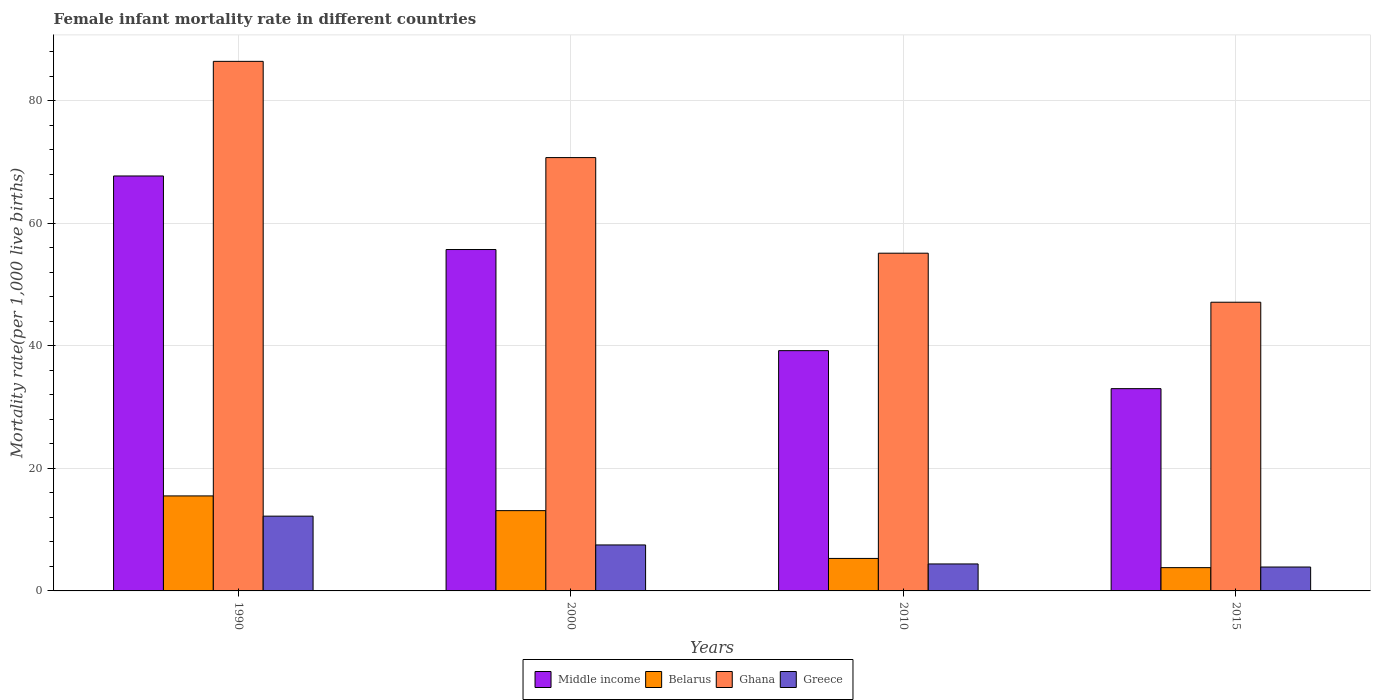How many different coloured bars are there?
Offer a very short reply. 4. Are the number of bars on each tick of the X-axis equal?
Provide a short and direct response. Yes. How many bars are there on the 1st tick from the left?
Give a very brief answer. 4. In how many cases, is the number of bars for a given year not equal to the number of legend labels?
Ensure brevity in your answer.  0. What is the female infant mortality rate in Greece in 2010?
Keep it short and to the point. 4.4. Across all years, what is the maximum female infant mortality rate in Ghana?
Give a very brief answer. 86.4. In which year was the female infant mortality rate in Greece minimum?
Make the answer very short. 2015. What is the total female infant mortality rate in Ghana in the graph?
Keep it short and to the point. 259.3. What is the difference between the female infant mortality rate in Greece in 2000 and that in 2015?
Ensure brevity in your answer.  3.6. What is the average female infant mortality rate in Middle income per year?
Give a very brief answer. 48.9. In the year 1990, what is the difference between the female infant mortality rate in Belarus and female infant mortality rate in Ghana?
Make the answer very short. -70.9. What is the ratio of the female infant mortality rate in Greece in 2000 to that in 2015?
Provide a succinct answer. 1.92. Is the difference between the female infant mortality rate in Belarus in 1990 and 2015 greater than the difference between the female infant mortality rate in Ghana in 1990 and 2015?
Keep it short and to the point. No. What is the difference between the highest and the second highest female infant mortality rate in Greece?
Ensure brevity in your answer.  4.7. What is the difference between the highest and the lowest female infant mortality rate in Middle income?
Keep it short and to the point. 34.7. Is it the case that in every year, the sum of the female infant mortality rate in Greece and female infant mortality rate in Ghana is greater than the sum of female infant mortality rate in Middle income and female infant mortality rate in Belarus?
Provide a succinct answer. No. How many bars are there?
Keep it short and to the point. 16. What is the difference between two consecutive major ticks on the Y-axis?
Ensure brevity in your answer.  20. Does the graph contain any zero values?
Offer a very short reply. No. How many legend labels are there?
Provide a succinct answer. 4. What is the title of the graph?
Keep it short and to the point. Female infant mortality rate in different countries. What is the label or title of the Y-axis?
Offer a very short reply. Mortality rate(per 1,0 live births). What is the Mortality rate(per 1,000 live births) of Middle income in 1990?
Offer a terse response. 67.7. What is the Mortality rate(per 1,000 live births) of Ghana in 1990?
Keep it short and to the point. 86.4. What is the Mortality rate(per 1,000 live births) of Middle income in 2000?
Provide a short and direct response. 55.7. What is the Mortality rate(per 1,000 live births) in Ghana in 2000?
Offer a very short reply. 70.7. What is the Mortality rate(per 1,000 live births) of Middle income in 2010?
Provide a short and direct response. 39.2. What is the Mortality rate(per 1,000 live births) in Belarus in 2010?
Offer a terse response. 5.3. What is the Mortality rate(per 1,000 live births) of Ghana in 2010?
Make the answer very short. 55.1. What is the Mortality rate(per 1,000 live births) of Ghana in 2015?
Provide a short and direct response. 47.1. Across all years, what is the maximum Mortality rate(per 1,000 live births) in Middle income?
Ensure brevity in your answer.  67.7. Across all years, what is the maximum Mortality rate(per 1,000 live births) in Ghana?
Provide a succinct answer. 86.4. Across all years, what is the maximum Mortality rate(per 1,000 live births) of Greece?
Make the answer very short. 12.2. Across all years, what is the minimum Mortality rate(per 1,000 live births) in Middle income?
Your answer should be compact. 33. Across all years, what is the minimum Mortality rate(per 1,000 live births) of Belarus?
Ensure brevity in your answer.  3.8. Across all years, what is the minimum Mortality rate(per 1,000 live births) in Ghana?
Provide a succinct answer. 47.1. What is the total Mortality rate(per 1,000 live births) in Middle income in the graph?
Your response must be concise. 195.6. What is the total Mortality rate(per 1,000 live births) of Belarus in the graph?
Your answer should be very brief. 37.7. What is the total Mortality rate(per 1,000 live births) of Ghana in the graph?
Keep it short and to the point. 259.3. What is the difference between the Mortality rate(per 1,000 live births) in Middle income in 1990 and that in 2000?
Keep it short and to the point. 12. What is the difference between the Mortality rate(per 1,000 live births) in Belarus in 1990 and that in 2000?
Offer a very short reply. 2.4. What is the difference between the Mortality rate(per 1,000 live births) in Middle income in 1990 and that in 2010?
Your answer should be compact. 28.5. What is the difference between the Mortality rate(per 1,000 live births) of Ghana in 1990 and that in 2010?
Ensure brevity in your answer.  31.3. What is the difference between the Mortality rate(per 1,000 live births) of Greece in 1990 and that in 2010?
Your answer should be compact. 7.8. What is the difference between the Mortality rate(per 1,000 live births) of Middle income in 1990 and that in 2015?
Offer a very short reply. 34.7. What is the difference between the Mortality rate(per 1,000 live births) in Belarus in 1990 and that in 2015?
Offer a terse response. 11.7. What is the difference between the Mortality rate(per 1,000 live births) in Ghana in 1990 and that in 2015?
Your response must be concise. 39.3. What is the difference between the Mortality rate(per 1,000 live births) of Greece in 2000 and that in 2010?
Provide a succinct answer. 3.1. What is the difference between the Mortality rate(per 1,000 live births) of Middle income in 2000 and that in 2015?
Ensure brevity in your answer.  22.7. What is the difference between the Mortality rate(per 1,000 live births) of Ghana in 2000 and that in 2015?
Provide a succinct answer. 23.6. What is the difference between the Mortality rate(per 1,000 live births) in Greece in 2000 and that in 2015?
Ensure brevity in your answer.  3.6. What is the difference between the Mortality rate(per 1,000 live births) in Middle income in 1990 and the Mortality rate(per 1,000 live births) in Belarus in 2000?
Offer a very short reply. 54.6. What is the difference between the Mortality rate(per 1,000 live births) in Middle income in 1990 and the Mortality rate(per 1,000 live births) in Ghana in 2000?
Your answer should be very brief. -3. What is the difference between the Mortality rate(per 1,000 live births) of Middle income in 1990 and the Mortality rate(per 1,000 live births) of Greece in 2000?
Provide a succinct answer. 60.2. What is the difference between the Mortality rate(per 1,000 live births) of Belarus in 1990 and the Mortality rate(per 1,000 live births) of Ghana in 2000?
Offer a terse response. -55.2. What is the difference between the Mortality rate(per 1,000 live births) of Belarus in 1990 and the Mortality rate(per 1,000 live births) of Greece in 2000?
Make the answer very short. 8. What is the difference between the Mortality rate(per 1,000 live births) in Ghana in 1990 and the Mortality rate(per 1,000 live births) in Greece in 2000?
Provide a succinct answer. 78.9. What is the difference between the Mortality rate(per 1,000 live births) in Middle income in 1990 and the Mortality rate(per 1,000 live births) in Belarus in 2010?
Offer a terse response. 62.4. What is the difference between the Mortality rate(per 1,000 live births) of Middle income in 1990 and the Mortality rate(per 1,000 live births) of Greece in 2010?
Keep it short and to the point. 63.3. What is the difference between the Mortality rate(per 1,000 live births) in Belarus in 1990 and the Mortality rate(per 1,000 live births) in Ghana in 2010?
Give a very brief answer. -39.6. What is the difference between the Mortality rate(per 1,000 live births) of Belarus in 1990 and the Mortality rate(per 1,000 live births) of Greece in 2010?
Ensure brevity in your answer.  11.1. What is the difference between the Mortality rate(per 1,000 live births) in Ghana in 1990 and the Mortality rate(per 1,000 live births) in Greece in 2010?
Make the answer very short. 82. What is the difference between the Mortality rate(per 1,000 live births) in Middle income in 1990 and the Mortality rate(per 1,000 live births) in Belarus in 2015?
Offer a terse response. 63.9. What is the difference between the Mortality rate(per 1,000 live births) in Middle income in 1990 and the Mortality rate(per 1,000 live births) in Ghana in 2015?
Your answer should be compact. 20.6. What is the difference between the Mortality rate(per 1,000 live births) in Middle income in 1990 and the Mortality rate(per 1,000 live births) in Greece in 2015?
Offer a very short reply. 63.8. What is the difference between the Mortality rate(per 1,000 live births) of Belarus in 1990 and the Mortality rate(per 1,000 live births) of Ghana in 2015?
Your answer should be compact. -31.6. What is the difference between the Mortality rate(per 1,000 live births) of Belarus in 1990 and the Mortality rate(per 1,000 live births) of Greece in 2015?
Your response must be concise. 11.6. What is the difference between the Mortality rate(per 1,000 live births) in Ghana in 1990 and the Mortality rate(per 1,000 live births) in Greece in 2015?
Make the answer very short. 82.5. What is the difference between the Mortality rate(per 1,000 live births) in Middle income in 2000 and the Mortality rate(per 1,000 live births) in Belarus in 2010?
Your response must be concise. 50.4. What is the difference between the Mortality rate(per 1,000 live births) of Middle income in 2000 and the Mortality rate(per 1,000 live births) of Ghana in 2010?
Ensure brevity in your answer.  0.6. What is the difference between the Mortality rate(per 1,000 live births) of Middle income in 2000 and the Mortality rate(per 1,000 live births) of Greece in 2010?
Offer a terse response. 51.3. What is the difference between the Mortality rate(per 1,000 live births) in Belarus in 2000 and the Mortality rate(per 1,000 live births) in Ghana in 2010?
Your answer should be very brief. -42. What is the difference between the Mortality rate(per 1,000 live births) of Ghana in 2000 and the Mortality rate(per 1,000 live births) of Greece in 2010?
Your answer should be very brief. 66.3. What is the difference between the Mortality rate(per 1,000 live births) of Middle income in 2000 and the Mortality rate(per 1,000 live births) of Belarus in 2015?
Ensure brevity in your answer.  51.9. What is the difference between the Mortality rate(per 1,000 live births) in Middle income in 2000 and the Mortality rate(per 1,000 live births) in Greece in 2015?
Keep it short and to the point. 51.8. What is the difference between the Mortality rate(per 1,000 live births) in Belarus in 2000 and the Mortality rate(per 1,000 live births) in Ghana in 2015?
Ensure brevity in your answer.  -34. What is the difference between the Mortality rate(per 1,000 live births) of Belarus in 2000 and the Mortality rate(per 1,000 live births) of Greece in 2015?
Provide a short and direct response. 9.2. What is the difference between the Mortality rate(per 1,000 live births) in Ghana in 2000 and the Mortality rate(per 1,000 live births) in Greece in 2015?
Provide a short and direct response. 66.8. What is the difference between the Mortality rate(per 1,000 live births) in Middle income in 2010 and the Mortality rate(per 1,000 live births) in Belarus in 2015?
Make the answer very short. 35.4. What is the difference between the Mortality rate(per 1,000 live births) of Middle income in 2010 and the Mortality rate(per 1,000 live births) of Ghana in 2015?
Your answer should be compact. -7.9. What is the difference between the Mortality rate(per 1,000 live births) of Middle income in 2010 and the Mortality rate(per 1,000 live births) of Greece in 2015?
Keep it short and to the point. 35.3. What is the difference between the Mortality rate(per 1,000 live births) of Belarus in 2010 and the Mortality rate(per 1,000 live births) of Ghana in 2015?
Offer a terse response. -41.8. What is the difference between the Mortality rate(per 1,000 live births) of Belarus in 2010 and the Mortality rate(per 1,000 live births) of Greece in 2015?
Offer a very short reply. 1.4. What is the difference between the Mortality rate(per 1,000 live births) in Ghana in 2010 and the Mortality rate(per 1,000 live births) in Greece in 2015?
Ensure brevity in your answer.  51.2. What is the average Mortality rate(per 1,000 live births) in Middle income per year?
Offer a terse response. 48.9. What is the average Mortality rate(per 1,000 live births) of Belarus per year?
Ensure brevity in your answer.  9.43. What is the average Mortality rate(per 1,000 live births) of Ghana per year?
Your response must be concise. 64.83. What is the average Mortality rate(per 1,000 live births) in Greece per year?
Ensure brevity in your answer.  7. In the year 1990, what is the difference between the Mortality rate(per 1,000 live births) in Middle income and Mortality rate(per 1,000 live births) in Belarus?
Your response must be concise. 52.2. In the year 1990, what is the difference between the Mortality rate(per 1,000 live births) of Middle income and Mortality rate(per 1,000 live births) of Ghana?
Keep it short and to the point. -18.7. In the year 1990, what is the difference between the Mortality rate(per 1,000 live births) in Middle income and Mortality rate(per 1,000 live births) in Greece?
Give a very brief answer. 55.5. In the year 1990, what is the difference between the Mortality rate(per 1,000 live births) of Belarus and Mortality rate(per 1,000 live births) of Ghana?
Offer a very short reply. -70.9. In the year 1990, what is the difference between the Mortality rate(per 1,000 live births) in Ghana and Mortality rate(per 1,000 live births) in Greece?
Give a very brief answer. 74.2. In the year 2000, what is the difference between the Mortality rate(per 1,000 live births) of Middle income and Mortality rate(per 1,000 live births) of Belarus?
Provide a short and direct response. 42.6. In the year 2000, what is the difference between the Mortality rate(per 1,000 live births) of Middle income and Mortality rate(per 1,000 live births) of Greece?
Your response must be concise. 48.2. In the year 2000, what is the difference between the Mortality rate(per 1,000 live births) of Belarus and Mortality rate(per 1,000 live births) of Ghana?
Your answer should be compact. -57.6. In the year 2000, what is the difference between the Mortality rate(per 1,000 live births) in Ghana and Mortality rate(per 1,000 live births) in Greece?
Your answer should be compact. 63.2. In the year 2010, what is the difference between the Mortality rate(per 1,000 live births) of Middle income and Mortality rate(per 1,000 live births) of Belarus?
Ensure brevity in your answer.  33.9. In the year 2010, what is the difference between the Mortality rate(per 1,000 live births) of Middle income and Mortality rate(per 1,000 live births) of Ghana?
Provide a succinct answer. -15.9. In the year 2010, what is the difference between the Mortality rate(per 1,000 live births) in Middle income and Mortality rate(per 1,000 live births) in Greece?
Your answer should be compact. 34.8. In the year 2010, what is the difference between the Mortality rate(per 1,000 live births) in Belarus and Mortality rate(per 1,000 live births) in Ghana?
Provide a succinct answer. -49.8. In the year 2010, what is the difference between the Mortality rate(per 1,000 live births) in Ghana and Mortality rate(per 1,000 live births) in Greece?
Keep it short and to the point. 50.7. In the year 2015, what is the difference between the Mortality rate(per 1,000 live births) in Middle income and Mortality rate(per 1,000 live births) in Belarus?
Ensure brevity in your answer.  29.2. In the year 2015, what is the difference between the Mortality rate(per 1,000 live births) in Middle income and Mortality rate(per 1,000 live births) in Ghana?
Make the answer very short. -14.1. In the year 2015, what is the difference between the Mortality rate(per 1,000 live births) in Middle income and Mortality rate(per 1,000 live births) in Greece?
Offer a terse response. 29.1. In the year 2015, what is the difference between the Mortality rate(per 1,000 live births) in Belarus and Mortality rate(per 1,000 live births) in Ghana?
Ensure brevity in your answer.  -43.3. In the year 2015, what is the difference between the Mortality rate(per 1,000 live births) of Belarus and Mortality rate(per 1,000 live births) of Greece?
Give a very brief answer. -0.1. In the year 2015, what is the difference between the Mortality rate(per 1,000 live births) in Ghana and Mortality rate(per 1,000 live births) in Greece?
Offer a very short reply. 43.2. What is the ratio of the Mortality rate(per 1,000 live births) of Middle income in 1990 to that in 2000?
Ensure brevity in your answer.  1.22. What is the ratio of the Mortality rate(per 1,000 live births) in Belarus in 1990 to that in 2000?
Your answer should be compact. 1.18. What is the ratio of the Mortality rate(per 1,000 live births) of Ghana in 1990 to that in 2000?
Give a very brief answer. 1.22. What is the ratio of the Mortality rate(per 1,000 live births) of Greece in 1990 to that in 2000?
Your answer should be compact. 1.63. What is the ratio of the Mortality rate(per 1,000 live births) of Middle income in 1990 to that in 2010?
Offer a terse response. 1.73. What is the ratio of the Mortality rate(per 1,000 live births) in Belarus in 1990 to that in 2010?
Provide a succinct answer. 2.92. What is the ratio of the Mortality rate(per 1,000 live births) in Ghana in 1990 to that in 2010?
Provide a succinct answer. 1.57. What is the ratio of the Mortality rate(per 1,000 live births) of Greece in 1990 to that in 2010?
Make the answer very short. 2.77. What is the ratio of the Mortality rate(per 1,000 live births) in Middle income in 1990 to that in 2015?
Keep it short and to the point. 2.05. What is the ratio of the Mortality rate(per 1,000 live births) in Belarus in 1990 to that in 2015?
Make the answer very short. 4.08. What is the ratio of the Mortality rate(per 1,000 live births) in Ghana in 1990 to that in 2015?
Your answer should be compact. 1.83. What is the ratio of the Mortality rate(per 1,000 live births) of Greece in 1990 to that in 2015?
Keep it short and to the point. 3.13. What is the ratio of the Mortality rate(per 1,000 live births) in Middle income in 2000 to that in 2010?
Your answer should be compact. 1.42. What is the ratio of the Mortality rate(per 1,000 live births) of Belarus in 2000 to that in 2010?
Provide a succinct answer. 2.47. What is the ratio of the Mortality rate(per 1,000 live births) of Ghana in 2000 to that in 2010?
Offer a very short reply. 1.28. What is the ratio of the Mortality rate(per 1,000 live births) in Greece in 2000 to that in 2010?
Keep it short and to the point. 1.7. What is the ratio of the Mortality rate(per 1,000 live births) in Middle income in 2000 to that in 2015?
Offer a very short reply. 1.69. What is the ratio of the Mortality rate(per 1,000 live births) in Belarus in 2000 to that in 2015?
Give a very brief answer. 3.45. What is the ratio of the Mortality rate(per 1,000 live births) of Ghana in 2000 to that in 2015?
Your answer should be compact. 1.5. What is the ratio of the Mortality rate(per 1,000 live births) of Greece in 2000 to that in 2015?
Offer a very short reply. 1.92. What is the ratio of the Mortality rate(per 1,000 live births) of Middle income in 2010 to that in 2015?
Your answer should be very brief. 1.19. What is the ratio of the Mortality rate(per 1,000 live births) of Belarus in 2010 to that in 2015?
Offer a very short reply. 1.39. What is the ratio of the Mortality rate(per 1,000 live births) in Ghana in 2010 to that in 2015?
Give a very brief answer. 1.17. What is the ratio of the Mortality rate(per 1,000 live births) in Greece in 2010 to that in 2015?
Offer a terse response. 1.13. What is the difference between the highest and the second highest Mortality rate(per 1,000 live births) of Middle income?
Your answer should be very brief. 12. What is the difference between the highest and the second highest Mortality rate(per 1,000 live births) of Belarus?
Provide a succinct answer. 2.4. What is the difference between the highest and the second highest Mortality rate(per 1,000 live births) of Greece?
Your response must be concise. 4.7. What is the difference between the highest and the lowest Mortality rate(per 1,000 live births) in Middle income?
Your answer should be very brief. 34.7. What is the difference between the highest and the lowest Mortality rate(per 1,000 live births) of Ghana?
Provide a short and direct response. 39.3. What is the difference between the highest and the lowest Mortality rate(per 1,000 live births) of Greece?
Offer a terse response. 8.3. 